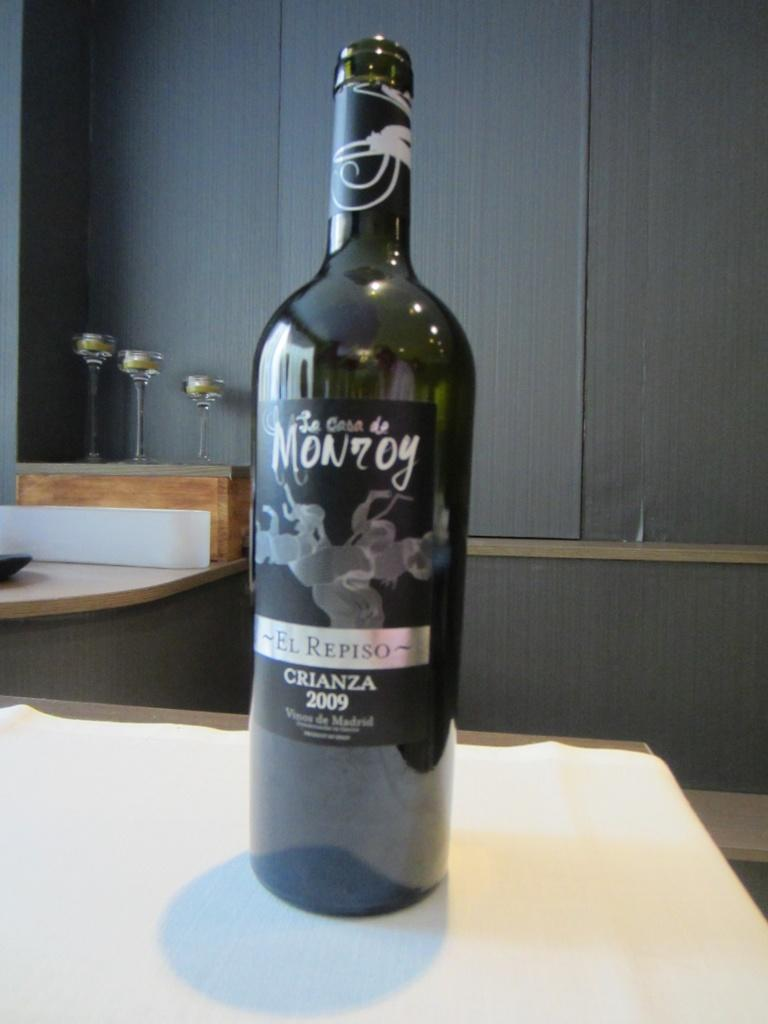<image>
Provide a brief description of the given image. On a table sits a bottle of El Repiso Crianza 2009. 